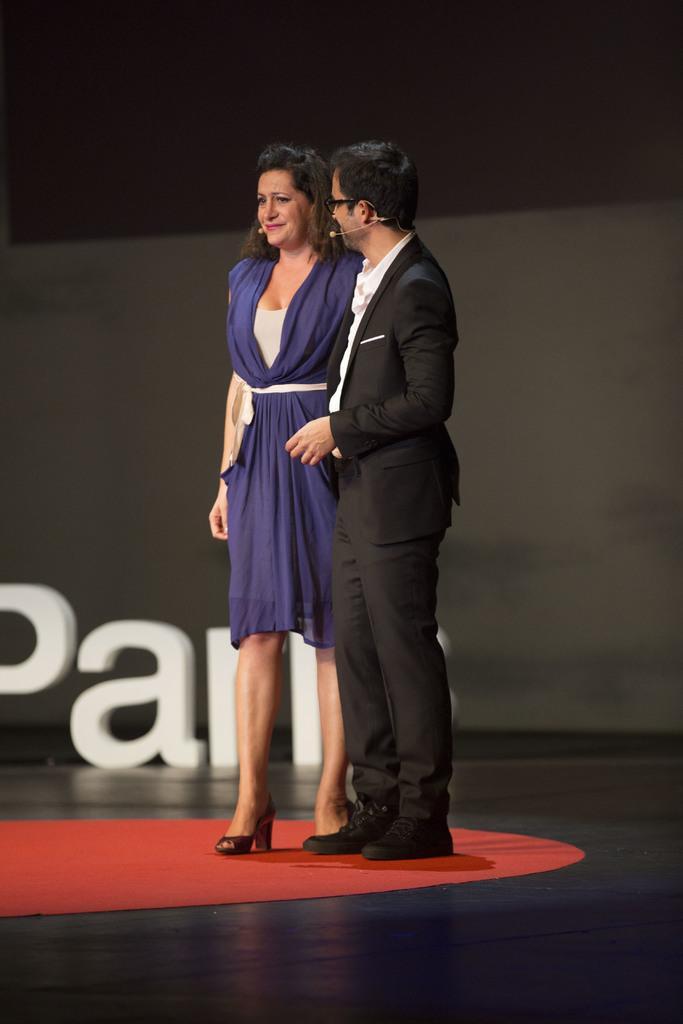Can you describe this image briefly? In this picture I can see there are two persons standing on the dais and the man is wearing a black blazer, white shirt, a pant and he has spectacles and a microphone and the woman standing beside him is wearing a blue dress and she is smiling and she has a microphone and there is a white object in the backdrop and there is a black wall. 